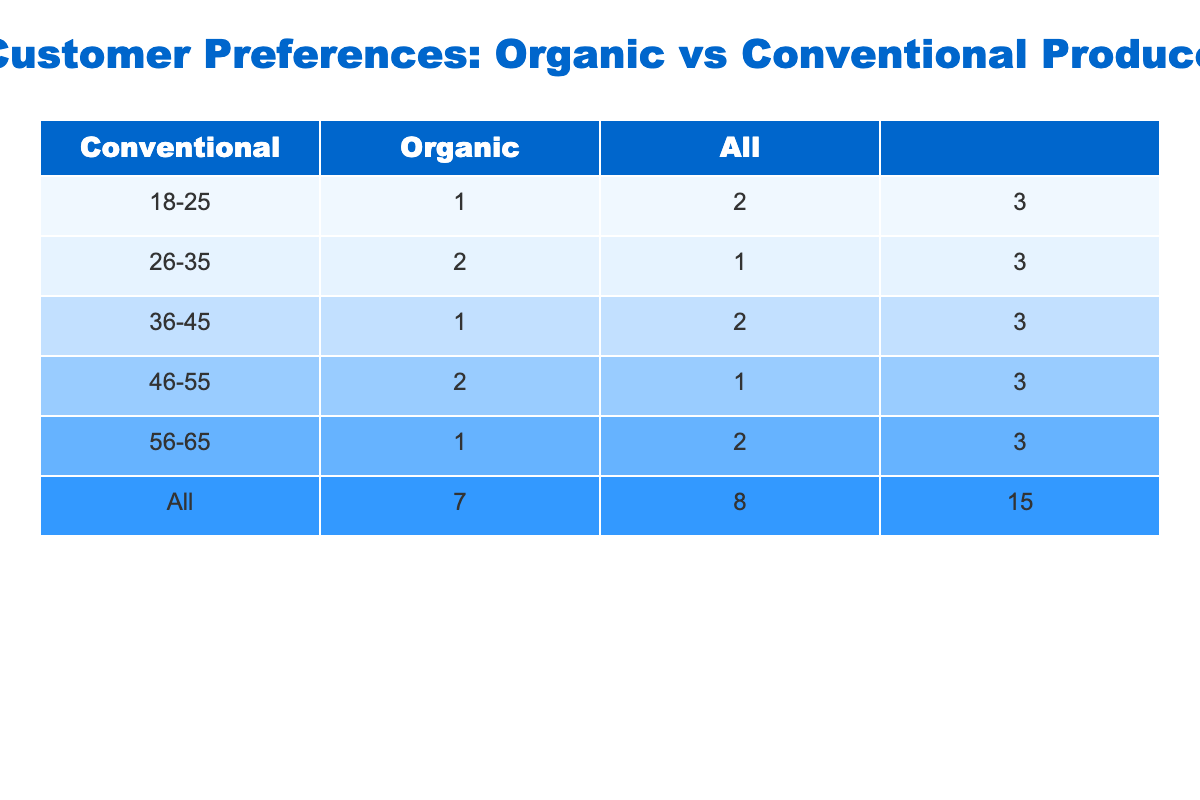What is the total number of customers who prefer organic produce? To find the total number of customers who prefer organic produce, I can look at the 'Organic' column in the table. By adding up the counts from each age group that prefers organic, I get 7 (18-25: 3, 26-35: 1, 36-45: 2, 46-55: 1, 56-65: 2)
Answer: 7 How many customers aged 36-45 prefer conventional produce? I can directly check the count of customers in the age group 36-45 under the 'Conventional' column. The table indicates that there are 1 customer in this age group who prefers conventional produce
Answer: 1 Is it true that more customers in the 56-65 age group prefer organic produce than those who prefer conventional? First, I can look at the counts in the 56-65 row for both organic and conventional. The count for organic is 2 and for conventional is 1. Since 2 (organic) is greater than 1 (conventional), the statement is true
Answer: Yes What is the difference in the number of customers between those who prefer organic and those who prefer conventional in the 26-35 age group? For the 26-35 age group, there are 1 customer who prefers organic and 2 who prefer conventional. To find the difference, I subtract: 2 (conventional) - 1 (organic) = 1
Answer: 1 What proportion of the total customers prefer organic compared to conventional? First, I need to count the total customers: 15. Then, I know that 7 prefer organic and 8 prefer conventional. The proportion of those who prefer organic is calculated as 7/15 ≈ 0.47 or 47%. Thus the proportion is roughly 0.47
Answer: 0.47 